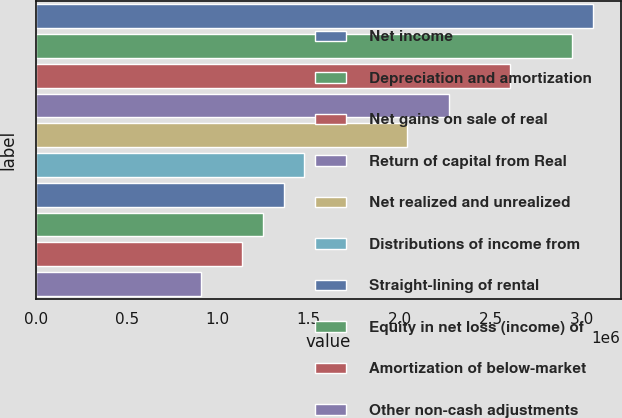Convert chart. <chart><loc_0><loc_0><loc_500><loc_500><bar_chart><fcel>Net income<fcel>Depreciation and amortization<fcel>Net gains on sale of real<fcel>Return of capital from Real<fcel>Net realized and unrealized<fcel>Distributions of income from<fcel>Straight-lining of rental<fcel>Equity in net loss (income) of<fcel>Amortization of below-market<fcel>Other non-cash adjustments<nl><fcel>3.06002e+06<fcel>2.94681e+06<fcel>2.60715e+06<fcel>2.2675e+06<fcel>2.04106e+06<fcel>1.47497e+06<fcel>1.36175e+06<fcel>1.24853e+06<fcel>1.13531e+06<fcel>908873<nl></chart> 